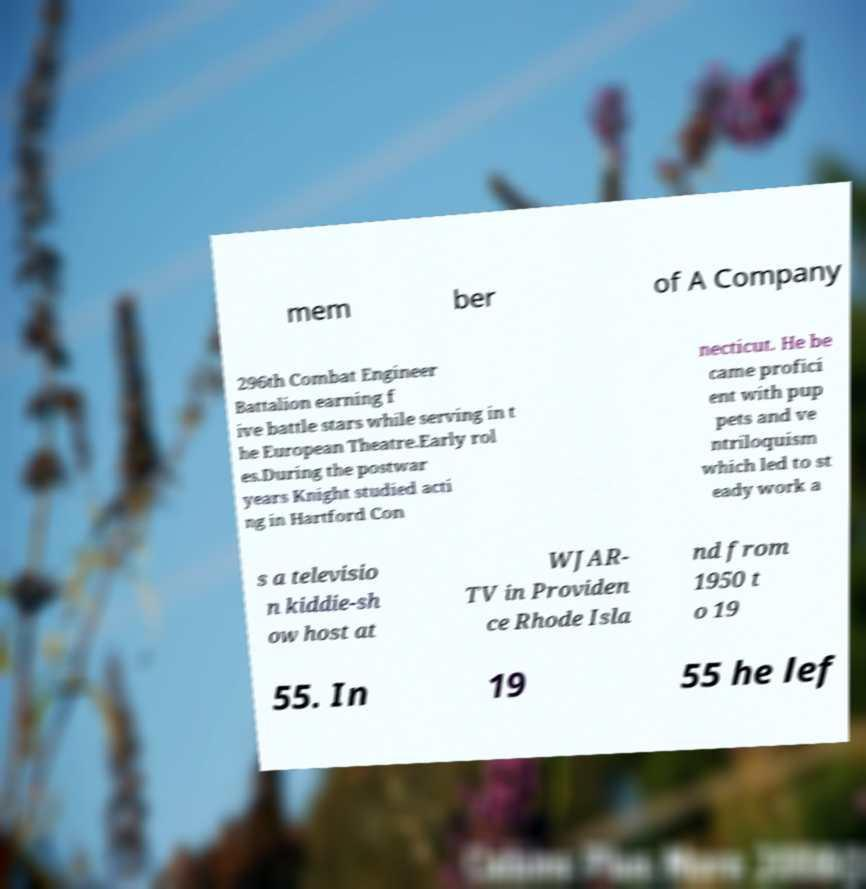Can you accurately transcribe the text from the provided image for me? mem ber of A Company 296th Combat Engineer Battalion earning f ive battle stars while serving in t he European Theatre.Early rol es.During the postwar years Knight studied acti ng in Hartford Con necticut. He be came profici ent with pup pets and ve ntriloquism which led to st eady work a s a televisio n kiddie-sh ow host at WJAR- TV in Providen ce Rhode Isla nd from 1950 t o 19 55. In 19 55 he lef 